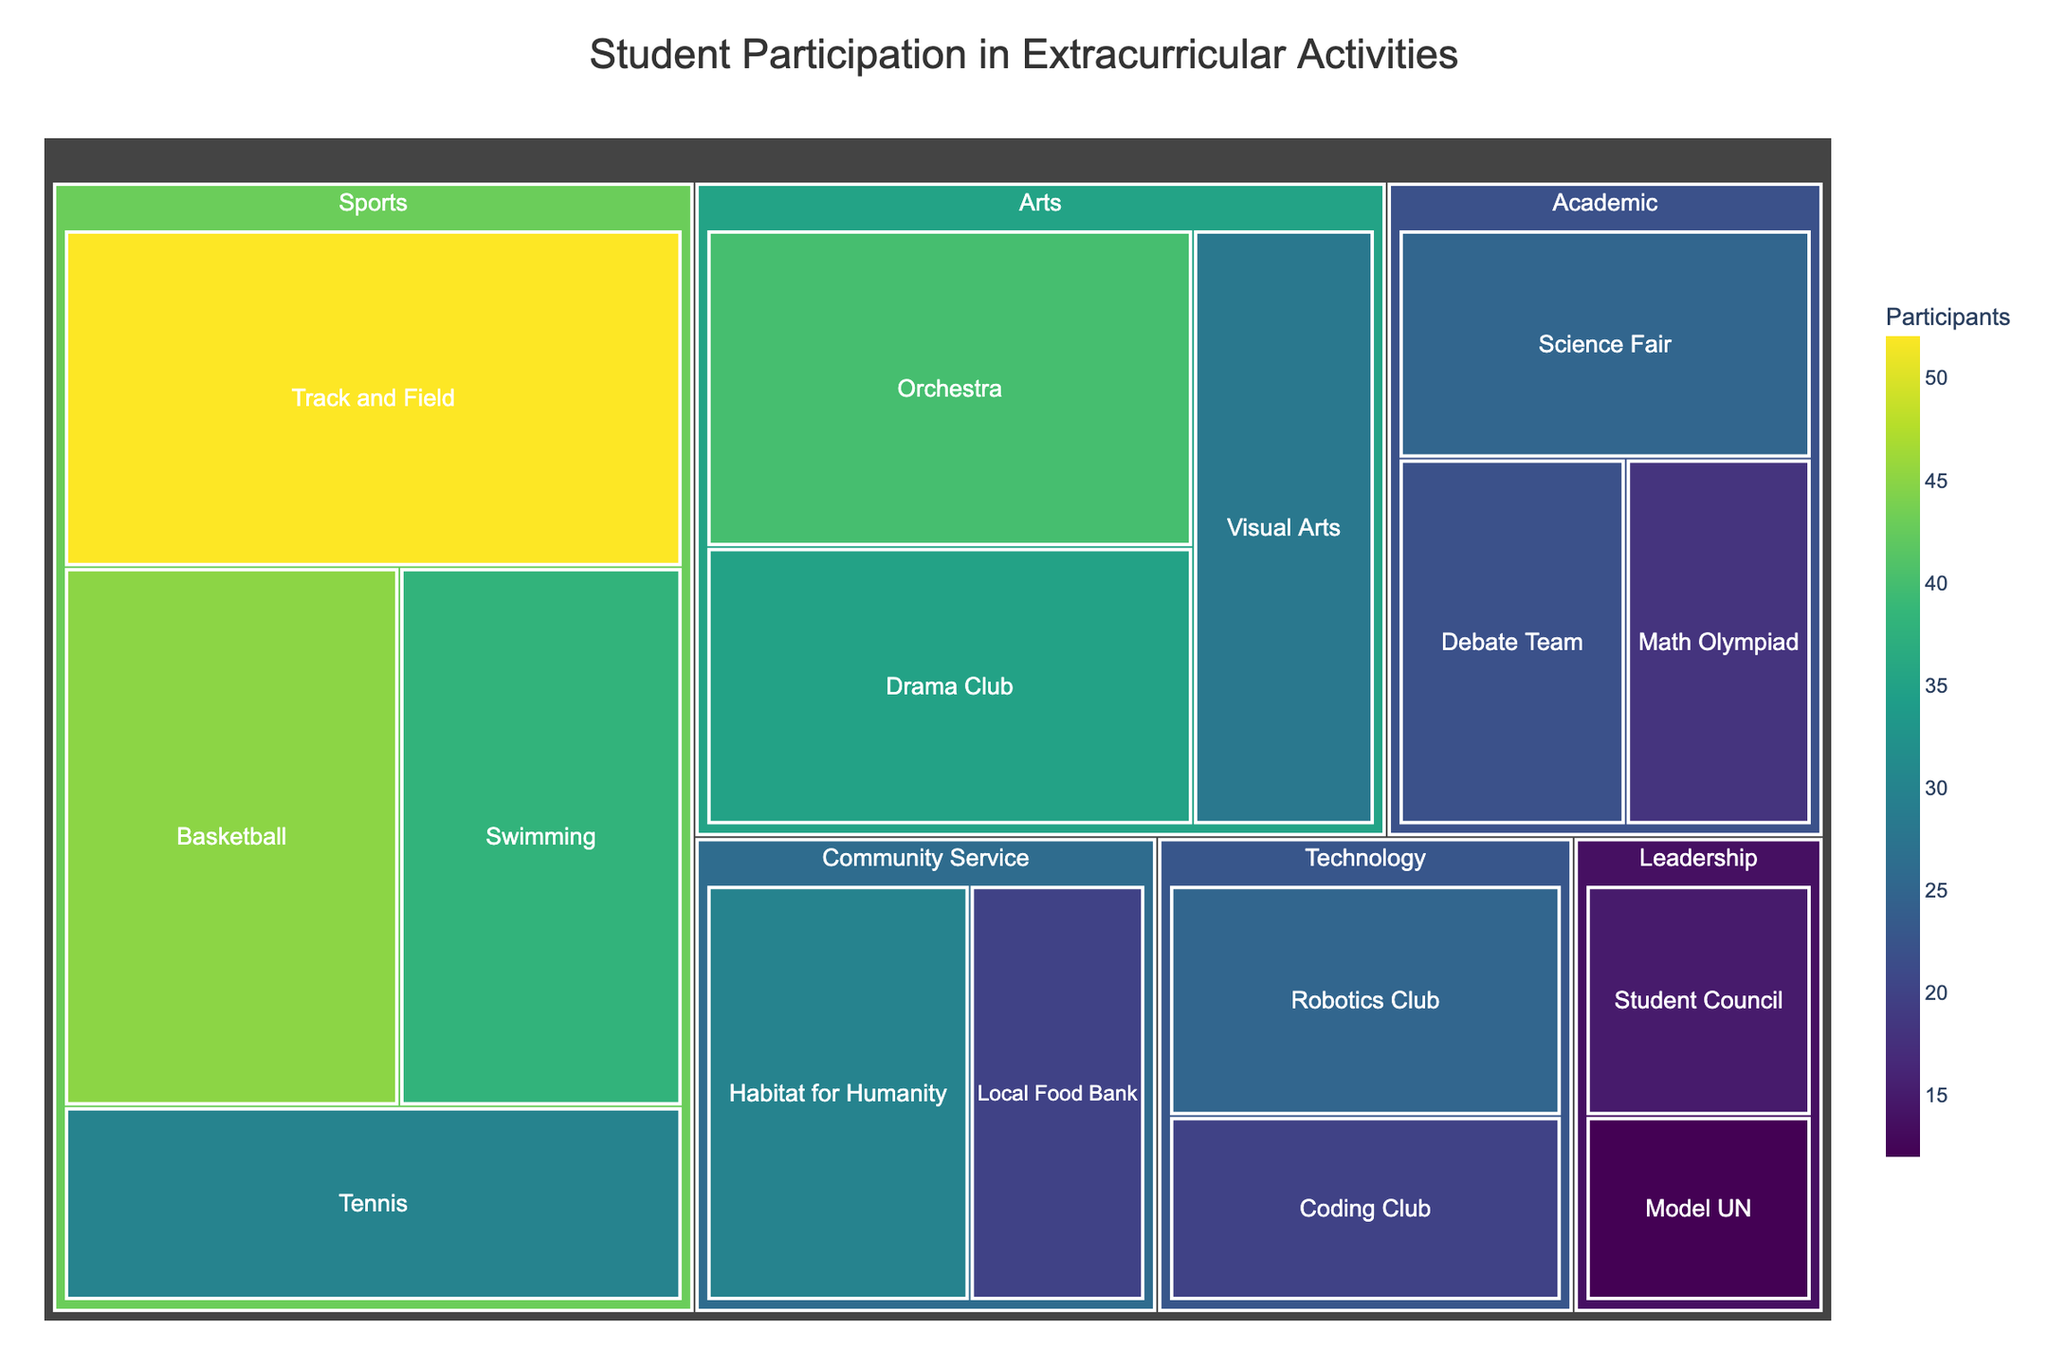what is the title of the treemap? The title is usually displayed at the top of the plot. In this treemap, the title helps viewers immediately understand the subject of the visualization.
Answer: Student Participation in Extracurricular Activities Which category has the most subcategories? To find this, look at each category and count how many subcategories are within it. "Sports," "Arts," "Academic," "Community Service," "Leadership," and "Technology" have different numbers of subcategories.
Answer: Sports What is the total number of participants in Academic activities? To get this number, sum the participants of the subcategories under Academic which include Debate Team, Math Olympiad, and Science Fair. 22 (Debate Team) + 18 (Math Olympiad) + 25 (Science Fair) = 65
Answer: 65 How does the number of participants in Basketball compare to Robotics Club? Look at the number of participants in both Basketball (45) and Robotics Club (25), and compare them to see which is greater.
Answer: Basketball has 20 more participants than Robotics Club Which subcategory in the Arts category has the fewest participants? Within the Arts category, compare the number of participants in Drama Club, Orchestra, and Visual Arts. Identify the subcategory with the smallest number.
Answer: Visual Arts What is the average number of participants per subcategory in the Community Service category? Add the participants of the two subcategories (Habitat for Humanity and Local Food Bank) and divide by 2. (30 + 20) / 2 = 25
Answer: 25 Which activity has fewer participants: Model UN or Coding Club? Look at the number of participants for both Model UN (12) and Coding Club (20) and identify which one has fewer participants.
Answer: Model UN How many more participants are there in Track and Field compared to Tennis? Subtract the number of participants in Tennis from the number of participants in Track and Field. 52 (Track and Field) - 30 (Tennis) = 22
Answer: 22 Is there any category that has exactly two subcategories? Count the subcategories within each category to identify if any category has exactly two subcategories (if not, state so). Community Service fits this criterion with Habitat for Humanity and Local Food Bank.
Answer: Yes, Community Service What is the total number of participants in the Sports category? Sum the participants of all subcategories under Sports. 45 (Basketball) + 38 (Swimming) + 52 (Track and Field) + 30 (Tennis) = 165
Answer: 165 